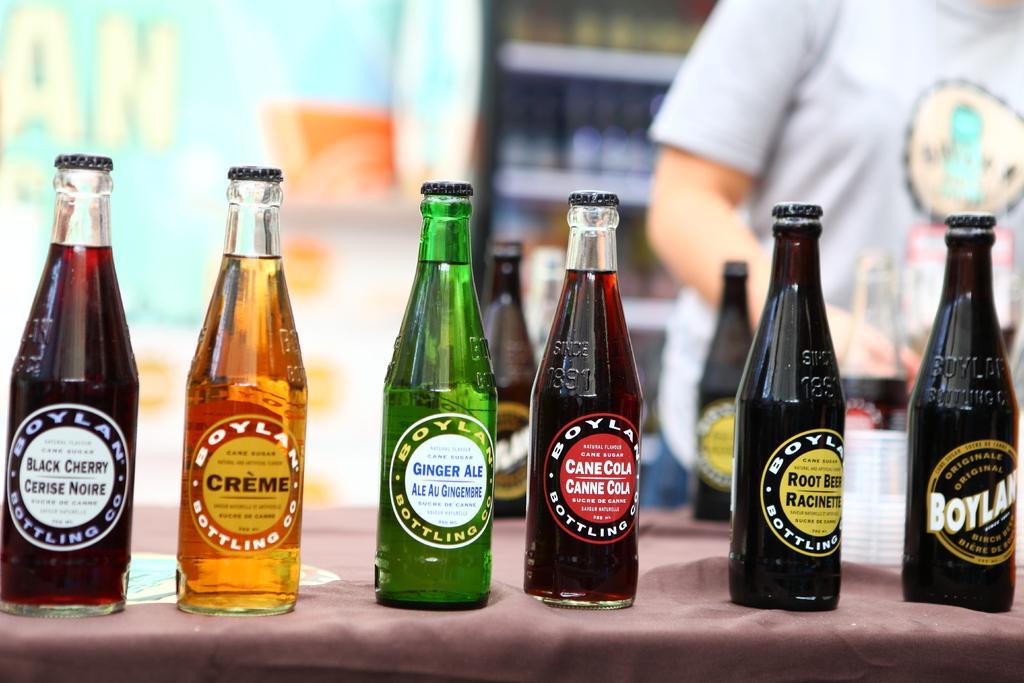Could you give a brief overview of what you see in this image? In this image i can see few glass bottles on the table. In the background i can see a person standing and a rack. 